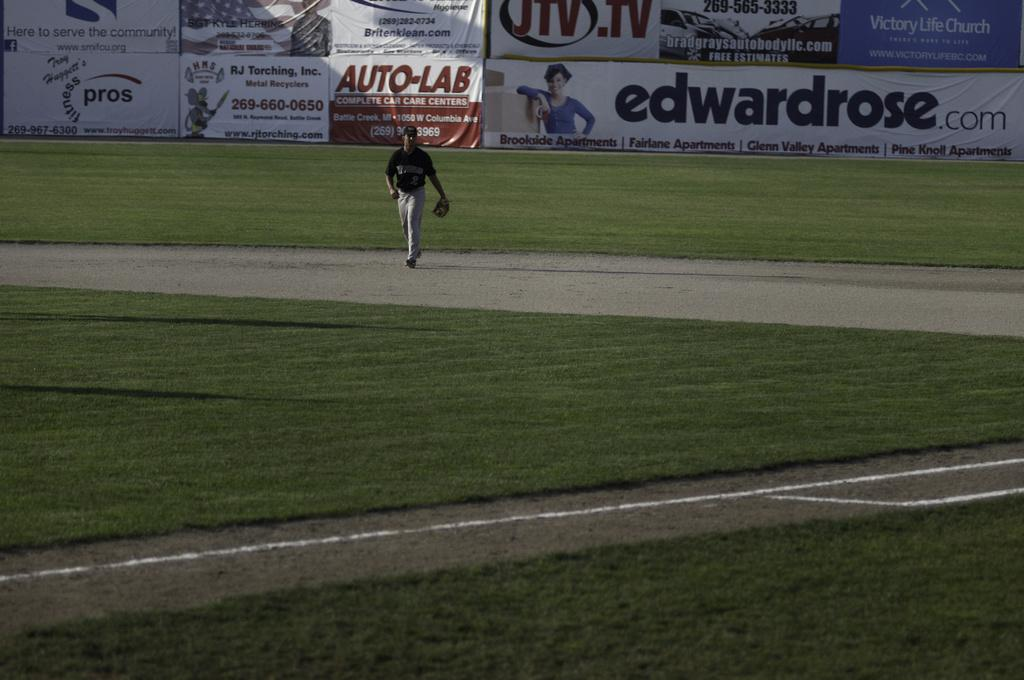Who is the main subject in the image? There is a man in the center of the image. What type of terrain is visible at the bottom side of the image? There is grassland at the bottom side of the image. What can be seen at the top side of the image? There are posters at the top side of the image. How many trees are visible in the image? There are no trees visible in the image. What type of harmony is being depicted in the image? The image does not depict any specific harmony; it features a man, grassland, and posters. 